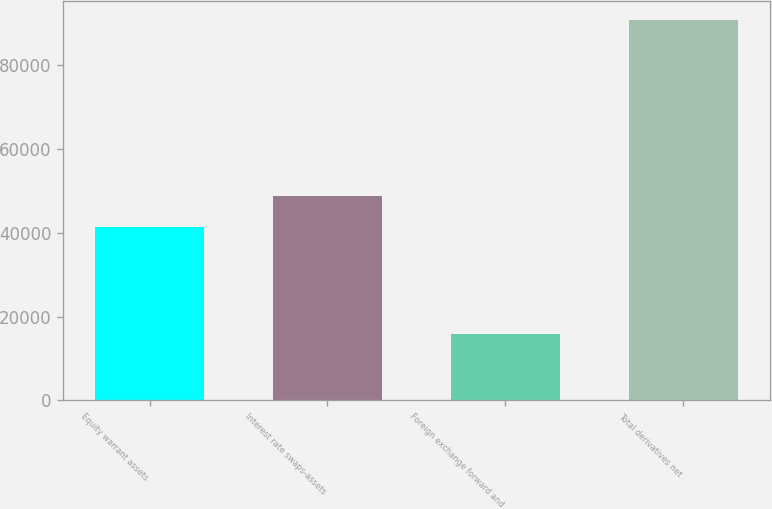<chart> <loc_0><loc_0><loc_500><loc_500><bar_chart><fcel>Equity warrant assets<fcel>Interest rate swaps-assets<fcel>Foreign exchange forward and<fcel>Total derivatives net<nl><fcel>41292<fcel>48780.3<fcel>15870<fcel>90753<nl></chart> 